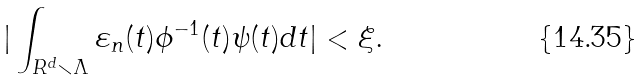Convert formula to latex. <formula><loc_0><loc_0><loc_500><loc_500>| \int _ { R ^ { d } \smallsetminus \Lambda } \varepsilon _ { n } ( t ) \phi ^ { - 1 } ( t ) \psi ( t ) d t | < \xi .</formula> 